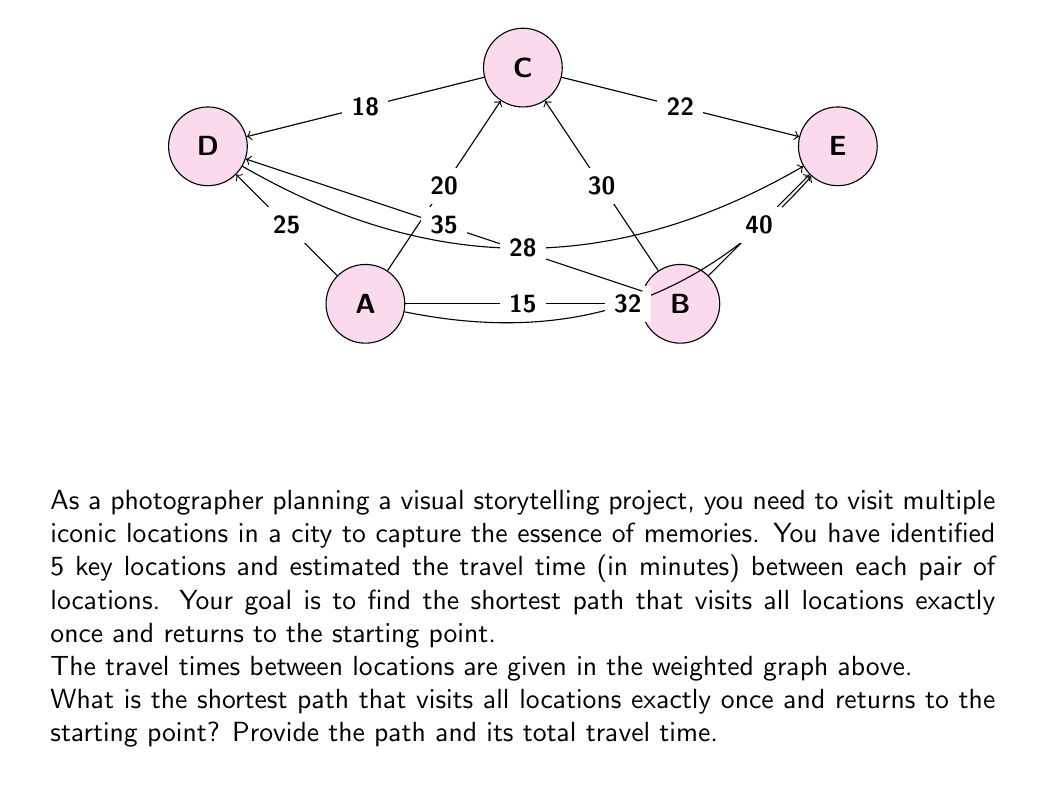Provide a solution to this math problem. To solve this problem, we can use the Traveling Salesman Problem (TSP) approach, which is a classic application of graph theory. Since we have a small number of locations (5), we can use a brute-force method to find the optimal solution.

Step 1: List all possible permutations of the 5 locations.
There are 5! = 120 possible permutations. However, since we can start at any location and the path is circular, we can fix one location (let's say A) as the starting point. This reduces the number of permutations to 4! = 24.

Step 2: Calculate the total travel time for each permutation.
For each permutation, we need to sum up the travel times between consecutive locations and add the time to return to the starting point.

Step 3: Find the permutation with the minimum total travel time.

After checking all permutations, we find that the shortest path is:

A → B → E → C → D → A

Let's calculate the total travel time for this path:
$$ \text{Total time} = AB + BE + EC + CD + DA $$
$$ = 15 + 40 + 22 + 18 + 25 = 120 \text{ minutes} $$

Step 4: Verify that this is indeed the shortest path by comparing it with other permutations.

For example, let's check another permutation: A → C → E → B → D → A
$$ \text{Total time} = AC + CE + EB + BD + DA $$
$$ = 20 + 22 + 40 + 35 + 25 = 142 \text{ minutes} $$

This is longer than our found shortest path, confirming that A → B → E → C → D → A is indeed the optimal solution.
Answer: A → B → E → C → D → A, 120 minutes 